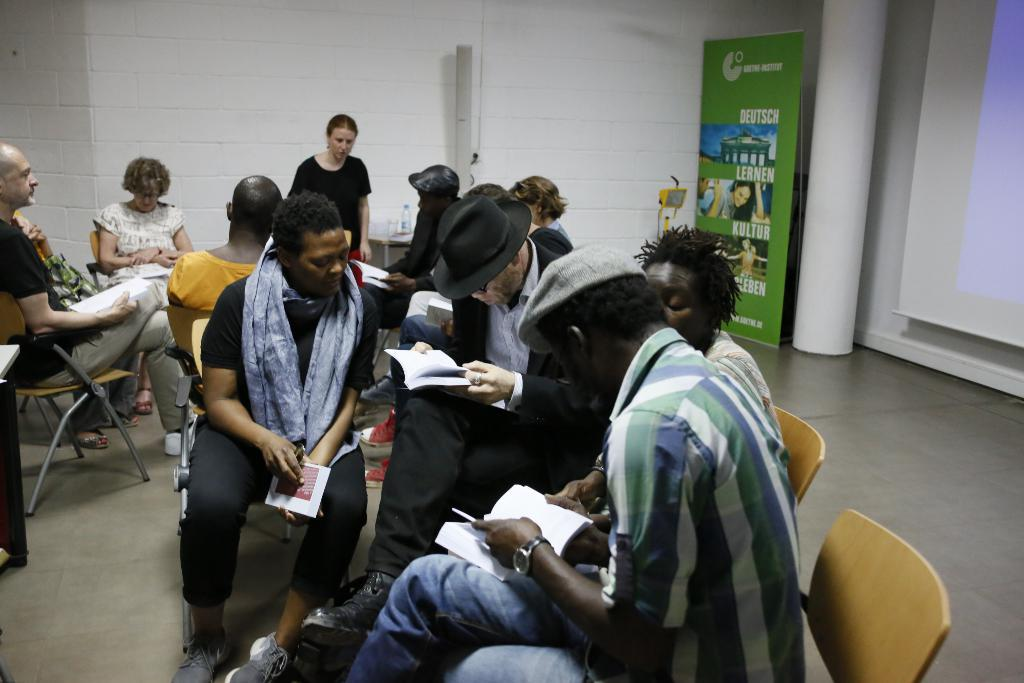How many people are in the image? There is a group of persons in the image. What are the persons in the image doing? The persons are sitting on chairs. Where is the scene taking place? The setting is in a room. What type of government is being discussed by the persons in the image? There is no indication in the image that the persons are discussing any type of government. 